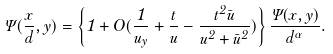<formula> <loc_0><loc_0><loc_500><loc_500>\Psi ( \frac { x } { d } , y ) = \left \{ 1 + O ( \frac { 1 } { u _ { y } } + \frac { t } { u } - \frac { t ^ { 2 } \bar { u } } { u ^ { 2 } + \bar { u } ^ { 2 } } ) \right \} \frac { \Psi ( x , y ) } { d ^ { \alpha } } .</formula> 